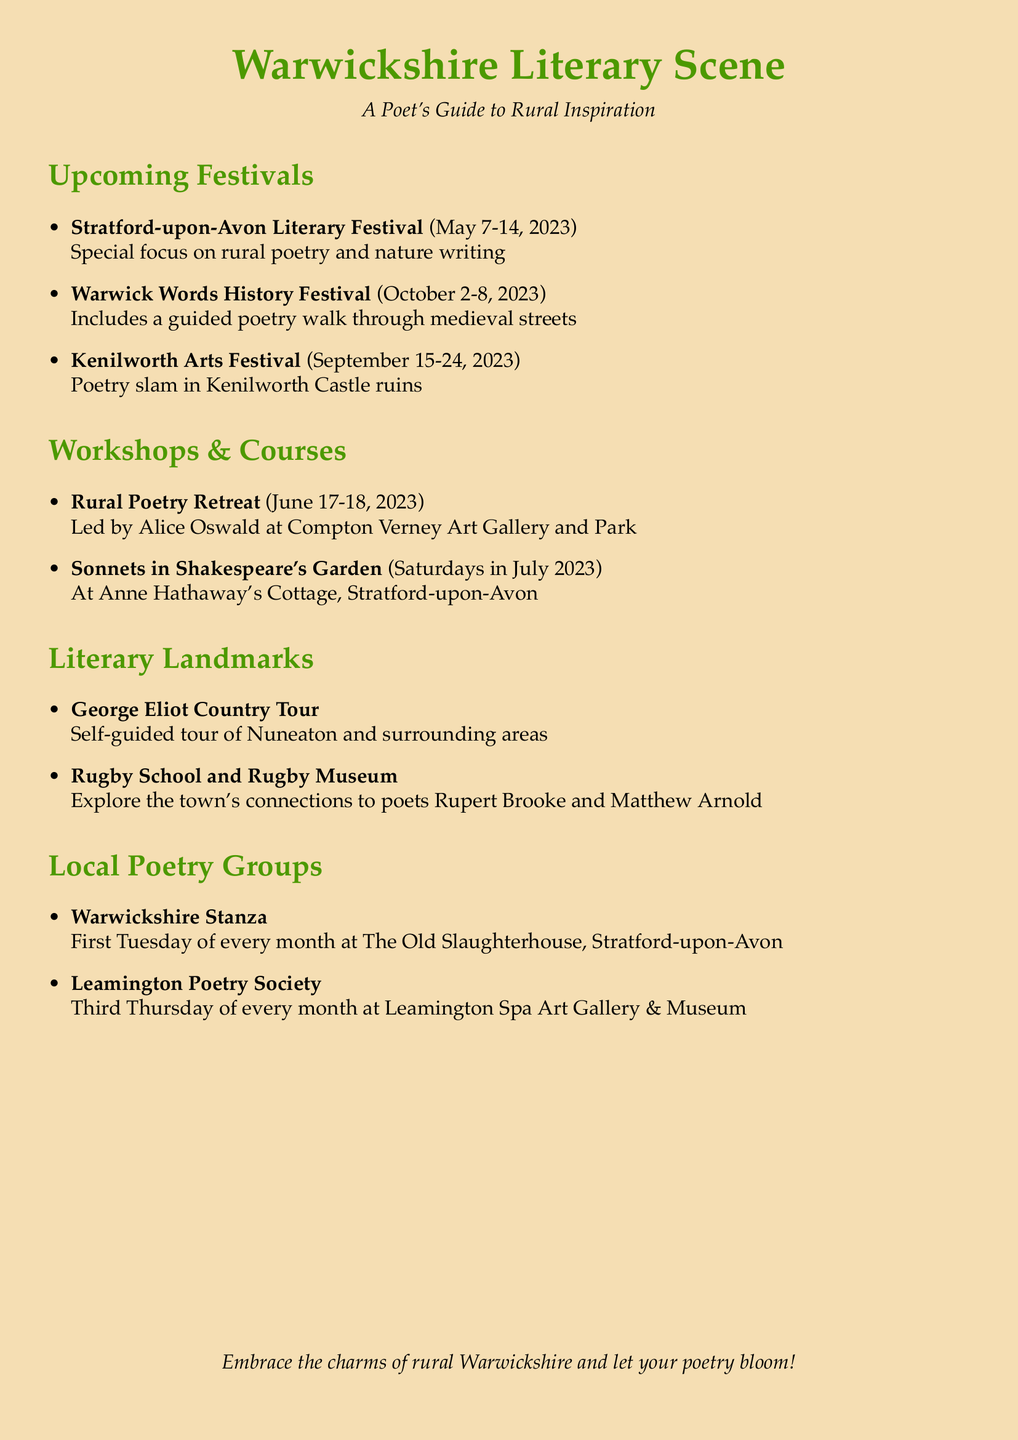What are the dates of the Stratford-upon-Avon Literary Festival? The dates of the Stratford-upon-Avon Literary Festival are mentioned in the document as May 7-14, 2023.
Answer: May 7-14, 2023 Where is the Warwick Words History Festival held? The location for the Warwick Words History Festival is provided in the document as Warwick.
Answer: Warwick Who is leading the Rural Poetry Retreat? The document states that the Rural Poetry Retreat is led by acclaimed nature poet Alice Oswald.
Answer: Alice Oswald What type of event occurs during the Kenilworth Arts Festival? The document highlights that a poetry slam competition will take place during the Kenilworth Arts Festival.
Answer: Poetry slam competition When do meetings for the Leamington Poetry Society occur? The document specifies that the Leamington Poetry Society meets on the third Thursday of every month.
Answer: Third Thursday of every month What is special about this year's Stratford-upon-Avon Literary Festival? The document mentions that there is a special focus on rural poetry and nature writing this year at the festival.
Answer: Rural poetry and nature writing What is the cost for all four sessions of Sonnets in Shakespeare's Garden? The document indicates that the cost for all four sessions of Sonnets in Shakespeare's Garden is £70.
Answer: £70 What location is associated with the George Eliot Country Tour? The document states that the George Eliot Country Tour is centered around Nuneaton and surrounding areas.
Answer: Nuneaton What does the Warwickshire Stanza group focus on? The document describes that the Warwickshire Stanza group welcomes poets of all levels to share and discuss their work.
Answer: Share and discuss their work 